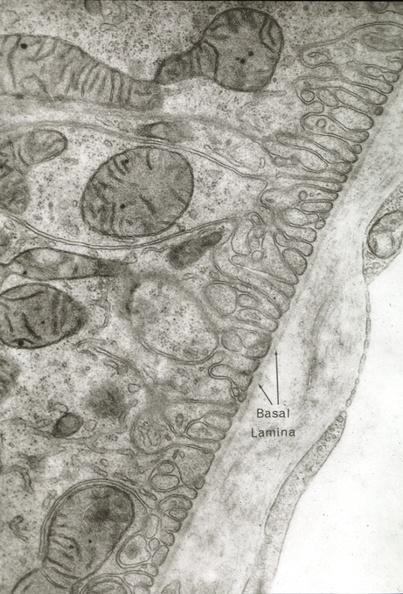what is present?
Answer the question using a single word or phrase. Cardiovascular 